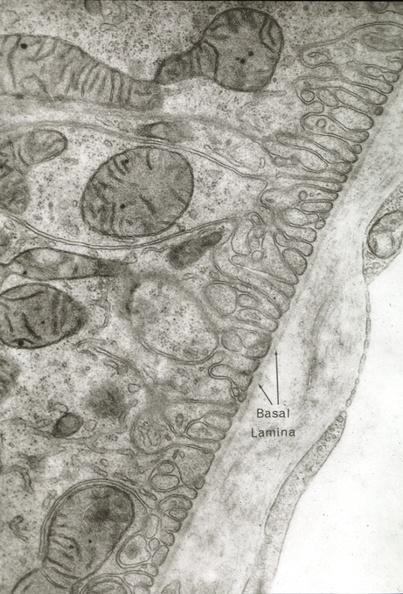what is present?
Answer the question using a single word or phrase. Cardiovascular 